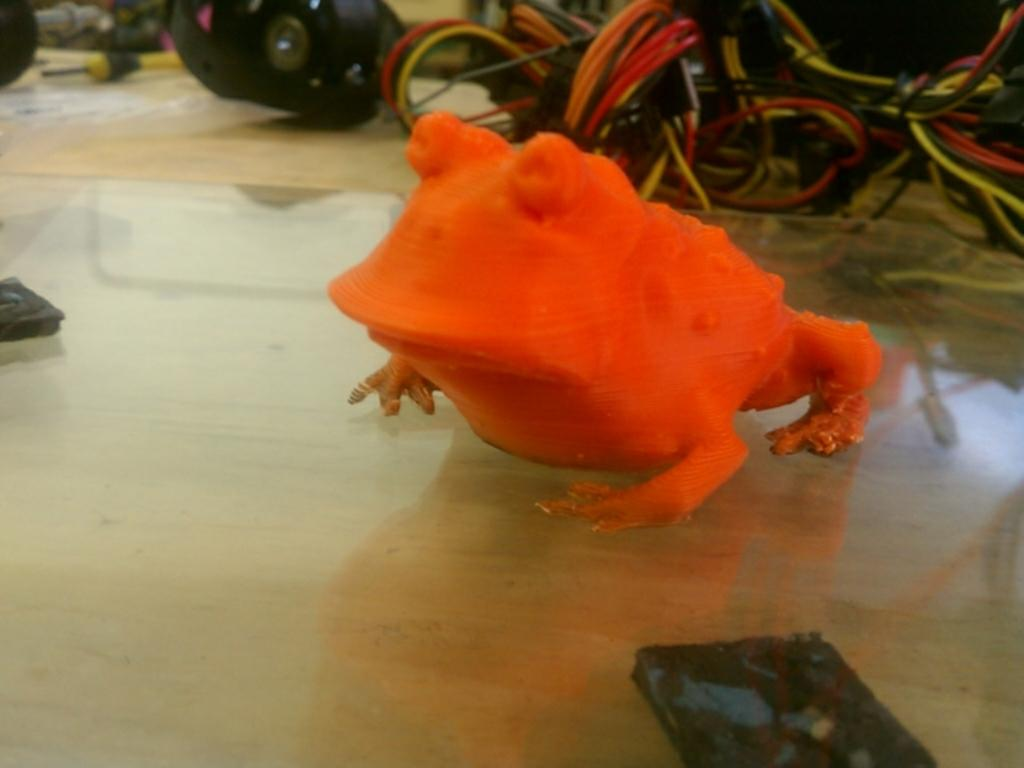What type of animal is in the image? There is an orange color frog in the image. Where is the frog located in the image? The frog is on the floor. What can be seen in the background of the image? There are wires visible in the background of the image. How many fingers can be seen on the frog in the image? Frogs do not have fingers like humans, so there are no fingers visible on the frog in the image. Is the frog part of a team in the image? There is no indication of a team or any team-related activity in the image. 